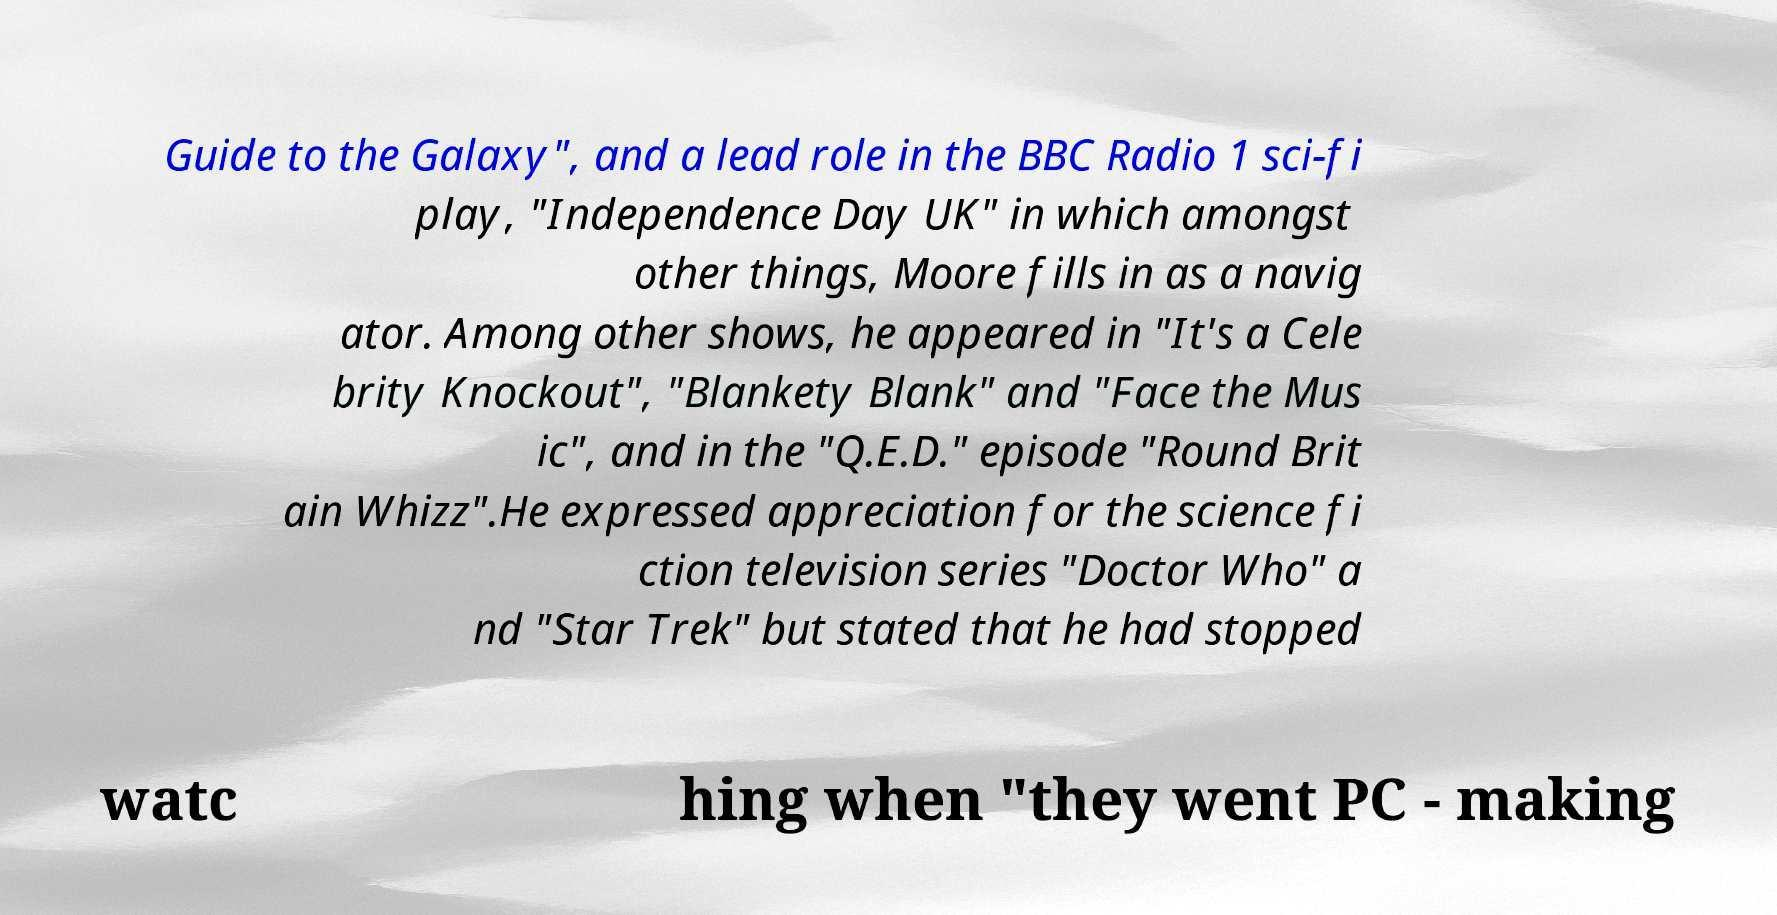Can you read and provide the text displayed in the image?This photo seems to have some interesting text. Can you extract and type it out for me? Guide to the Galaxy", and a lead role in the BBC Radio 1 sci-fi play, "Independence Day UK" in which amongst other things, Moore fills in as a navig ator. Among other shows, he appeared in "It's a Cele brity Knockout", "Blankety Blank" and "Face the Mus ic", and in the "Q.E.D." episode "Round Brit ain Whizz".He expressed appreciation for the science fi ction television series "Doctor Who" a nd "Star Trek" but stated that he had stopped watc hing when "they went PC - making 